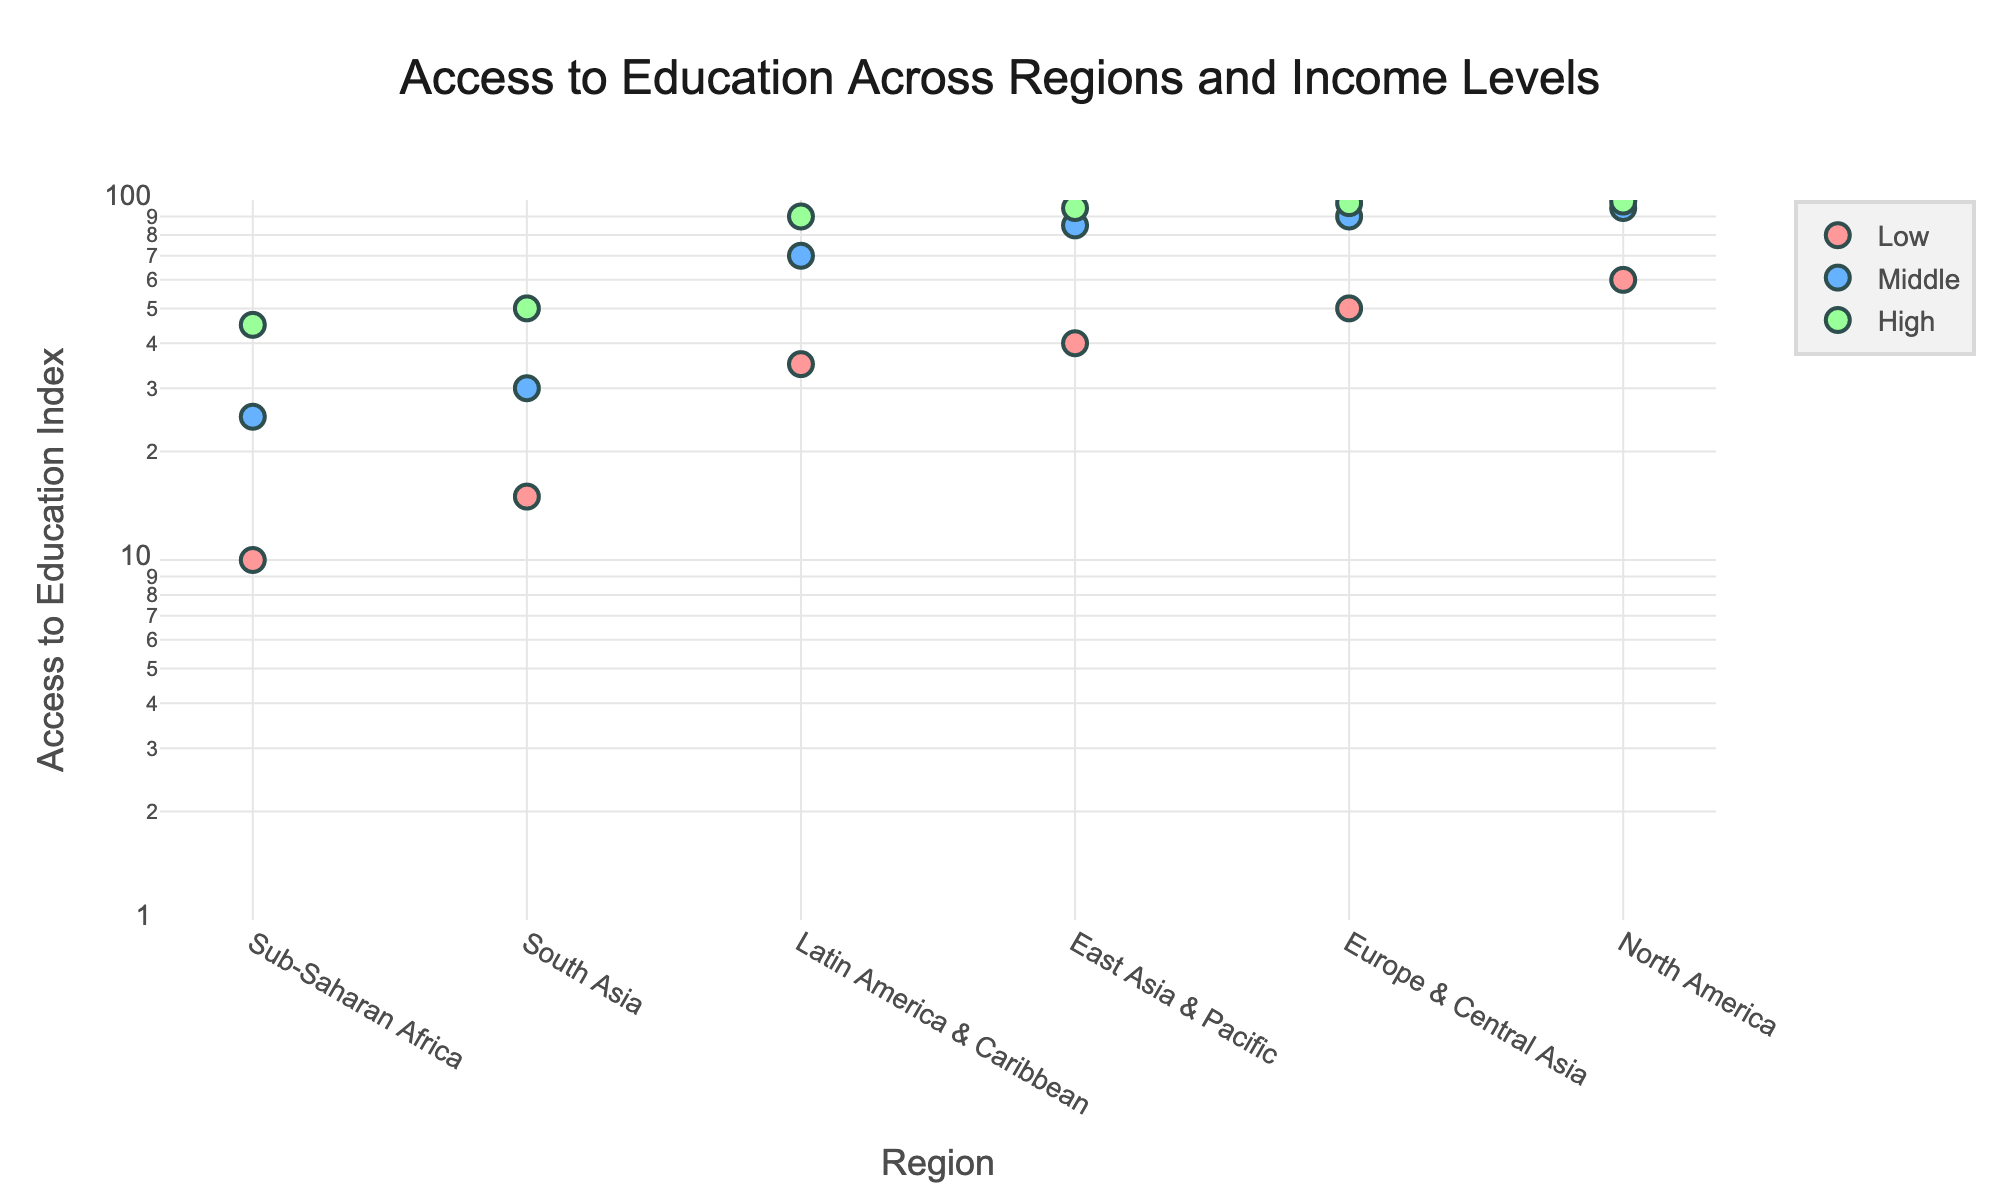What does the y-axis represent? The y-axis represents the 'Access to Education Index', which indicates the level of access to education in different regions and income levels. This axis is presented in a logarithmic scale with a range starting from 1 up to 100.
Answer: Access to Education Index What is the title of the figure? The title of the figure is 'Access to Education Across Regions and Income Levels'. This title is displayed at the top center of the plot, providing a clear overview of the topic depicted in the figure.
Answer: Access to Education Across Regions and Income Levels Which region has the highest access to education index for low-income levels? To find this, locate the points corresponding to the 'Low' income level on the x-axis and identify which region has the highest y-value. North America has the highest Access to Education Index for the Low-income level, with an index of 60.
Answer: North America How many income levels are represented in each region? Each region has three income levels represented: Low, Middle, and High. This is visible from the legend and the three distinct data points for each region on the x-axis.
Answer: Three What is the range of access to education index for Sub-Saharan Africa? Look at the y-values for Sub-Saharan Africa. The minimum value is 10 (Low Income) and the maximum value is 45 (High Income). Thus, the range is from 10 to 45.
Answer: 10 to 45 Which region shows the smallest difference in access to education index between low and high-income levels? Calculate the difference between the Access to Education Index values for low and high-income levels for each region. Europe & Central Asia shows the smallest difference, with values of 50 (Low) and 98 (High), yielding a difference of 48.
Answer: Europe & Central Asia Which region has the highest variability in access to education index across different income levels? Find the range for each region by subtracting the lowest value from the highest. South Asia has the highest variability with a range from 15 (Low) to 50 (High), yielding a variability of 35.
Answer: South Asia What pattern can be observed in the access to education index as we move from low to high-income levels? Observe the trend in y-values for different income levels across all regions. There is a consistent pattern where the Access to Education Index increases as the income level rises.
Answer: Increases 